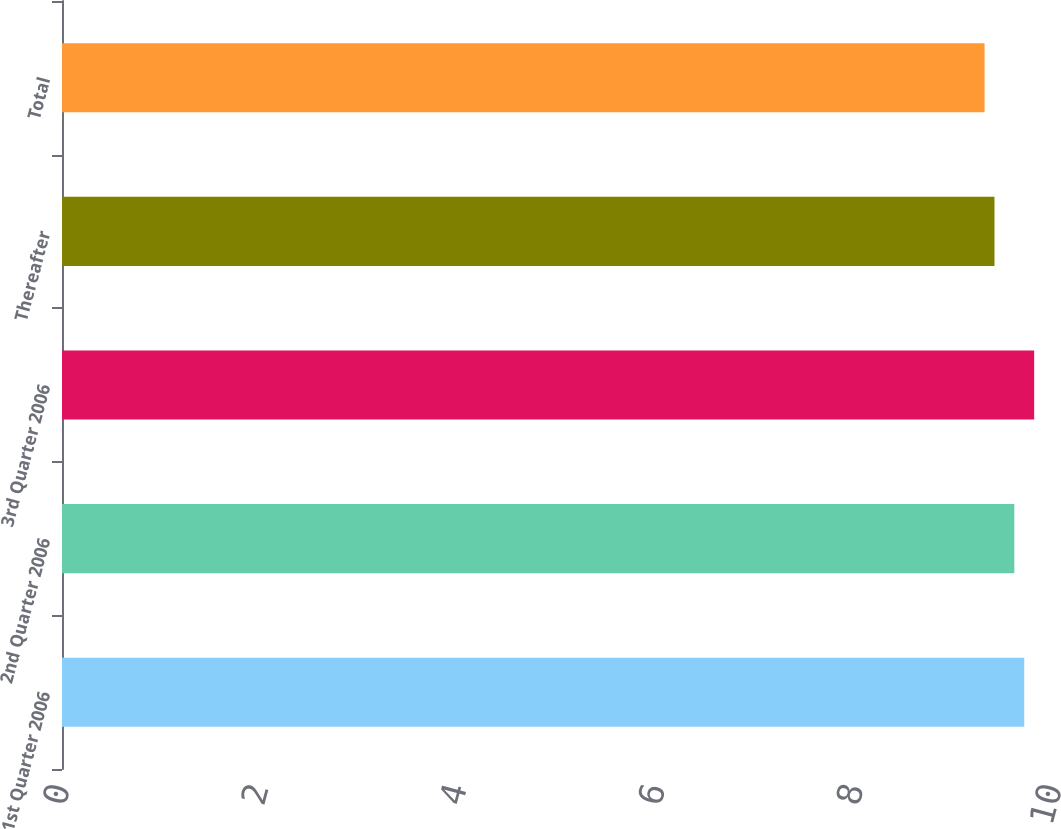Convert chart. <chart><loc_0><loc_0><loc_500><loc_500><bar_chart><fcel>1st Quarter 2006<fcel>2nd Quarter 2006<fcel>3rd Quarter 2006<fcel>Thereafter<fcel>Total<nl><fcel>9.7<fcel>9.6<fcel>9.8<fcel>9.4<fcel>9.3<nl></chart> 